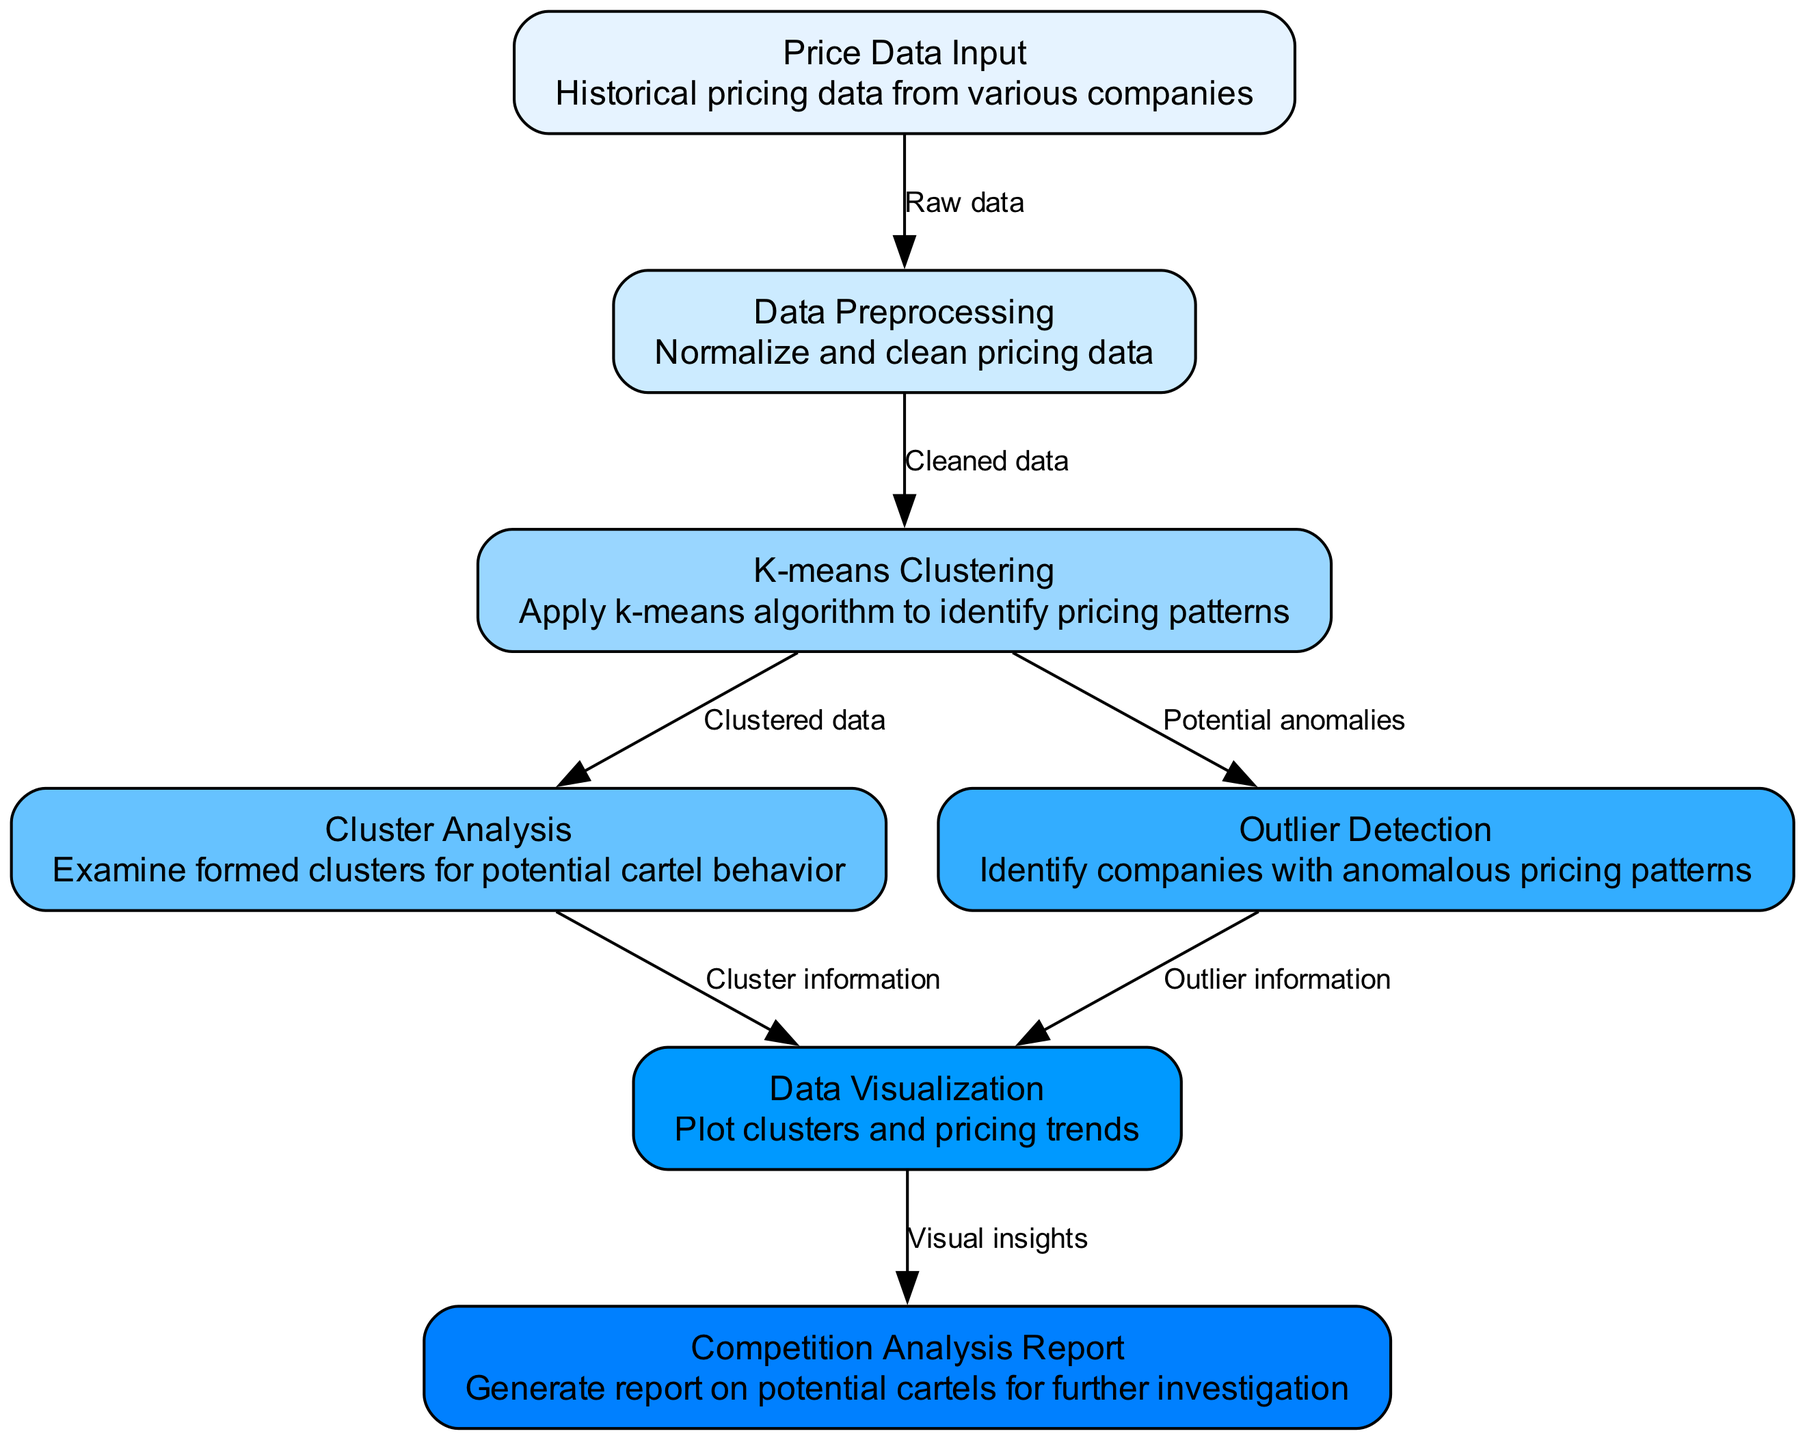What is the first step in the diagram? The first node in the diagram is "Price Data Input," which indicates that historical pricing data from various companies is the starting point for the analysis.
Answer: Price Data Input How many nodes are present in the diagram? The diagram indicates there are a total of seven nodes, as can be counted from the nodes section of the provided data.
Answer: Seven What does the "K-means Clustering" node do? The "K-means Clustering" node applies the k-means algorithm to the cleaned data to identify pricing patterns among the input companies.
Answer: Apply k-means algorithm Which node directly follows "Data Preprocessing"? The "K-means Clustering" node directly follows "Data Preprocessing," indicating that clustering is applied after the data has been cleaned and normalized.
Answer: K-means Clustering What is the relationship between "K-means Clustering" and "Outlier Detection"? Both nodes are derived from the "K-means Clustering" node; "Outlier Detection" identifies companies with potential anomalies based on the clustered data.
Answer: Potential anomalies What information flows from "Cluster Analysis" to "Data Visualization"? The edge from "Cluster Analysis" to "Data Visualization" carries the "Cluster information," which provides insights into the identified clusters for visualization purposes.
Answer: Cluster information Which node generates the final output report? The "Competition Analysis Report" node generates the final output, summarizing potential cartel behavior for further investigation based on the visual insights.
Answer: Competition Analysis Report What is identified in the "Outlier Detection" node? The "Outlier Detection" node identifies companies with anomalous pricing patterns that deviate from expected clustering results.
Answer: Anomalous pricing patterns What type of analysis does the "Cluster Analysis" node perform? The "Cluster Analysis" node examines the formed clusters to assess potential cartel behavior among the clustered companies based on their pricing patterns.
Answer: Examine formed clusters 